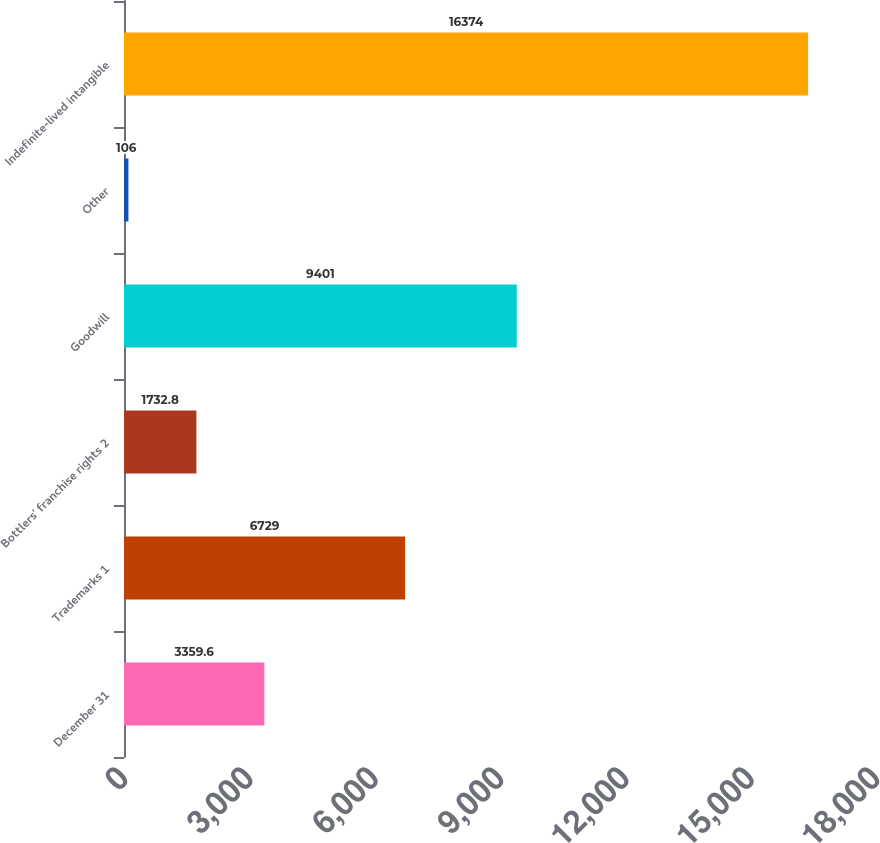Convert chart. <chart><loc_0><loc_0><loc_500><loc_500><bar_chart><fcel>December 31<fcel>Trademarks 1<fcel>Bottlers' franchise rights 2<fcel>Goodwill<fcel>Other<fcel>Indefinite-lived intangible<nl><fcel>3359.6<fcel>6729<fcel>1732.8<fcel>9401<fcel>106<fcel>16374<nl></chart> 